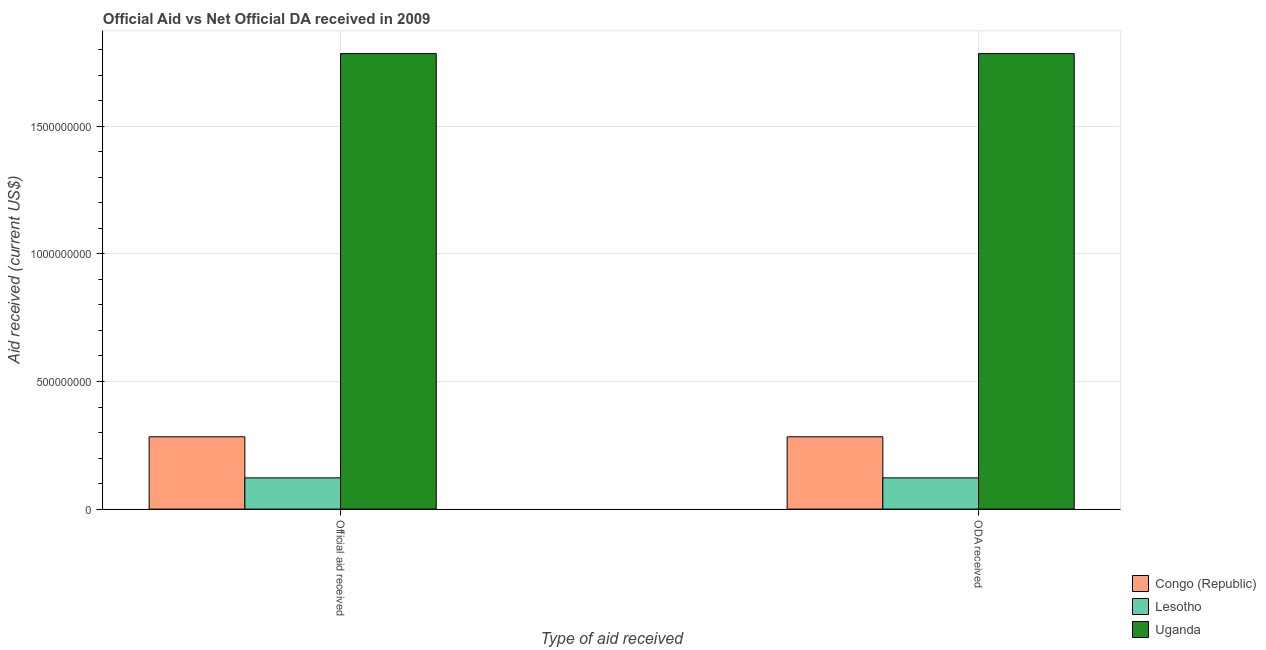How many different coloured bars are there?
Provide a succinct answer. 3. How many bars are there on the 2nd tick from the right?
Provide a short and direct response. 3. What is the label of the 2nd group of bars from the left?
Your response must be concise. ODA received. What is the oda received in Lesotho?
Ensure brevity in your answer.  1.22e+08. Across all countries, what is the maximum official aid received?
Provide a short and direct response. 1.78e+09. Across all countries, what is the minimum official aid received?
Your answer should be compact. 1.22e+08. In which country was the oda received maximum?
Offer a terse response. Uganda. In which country was the oda received minimum?
Offer a very short reply. Lesotho. What is the total oda received in the graph?
Provide a succinct answer. 2.19e+09. What is the difference between the oda received in Uganda and that in Lesotho?
Give a very brief answer. 1.66e+09. What is the difference between the oda received in Uganda and the official aid received in Congo (Republic)?
Provide a short and direct response. 1.50e+09. What is the average official aid received per country?
Give a very brief answer. 7.30e+08. What is the difference between the official aid received and oda received in Uganda?
Offer a very short reply. 0. What is the ratio of the official aid received in Uganda to that in Congo (Republic)?
Ensure brevity in your answer.  6.3. Is the official aid received in Congo (Republic) less than that in Uganda?
Provide a short and direct response. Yes. What does the 3rd bar from the left in ODA received represents?
Give a very brief answer. Uganda. What does the 1st bar from the right in ODA received represents?
Ensure brevity in your answer.  Uganda. What is the difference between two consecutive major ticks on the Y-axis?
Provide a short and direct response. 5.00e+08. Does the graph contain any zero values?
Your answer should be very brief. No. Where does the legend appear in the graph?
Keep it short and to the point. Bottom right. What is the title of the graph?
Keep it short and to the point. Official Aid vs Net Official DA received in 2009 . Does "Greece" appear as one of the legend labels in the graph?
Give a very brief answer. No. What is the label or title of the X-axis?
Give a very brief answer. Type of aid received. What is the label or title of the Y-axis?
Offer a very short reply. Aid received (current US$). What is the Aid received (current US$) of Congo (Republic) in Official aid received?
Provide a short and direct response. 2.83e+08. What is the Aid received (current US$) in Lesotho in Official aid received?
Make the answer very short. 1.22e+08. What is the Aid received (current US$) in Uganda in Official aid received?
Your answer should be very brief. 1.78e+09. What is the Aid received (current US$) in Congo (Republic) in ODA received?
Offer a terse response. 2.83e+08. What is the Aid received (current US$) of Lesotho in ODA received?
Provide a succinct answer. 1.22e+08. What is the Aid received (current US$) of Uganda in ODA received?
Offer a very short reply. 1.78e+09. Across all Type of aid received, what is the maximum Aid received (current US$) in Congo (Republic)?
Give a very brief answer. 2.83e+08. Across all Type of aid received, what is the maximum Aid received (current US$) in Lesotho?
Offer a very short reply. 1.22e+08. Across all Type of aid received, what is the maximum Aid received (current US$) of Uganda?
Offer a terse response. 1.78e+09. Across all Type of aid received, what is the minimum Aid received (current US$) of Congo (Republic)?
Your answer should be very brief. 2.83e+08. Across all Type of aid received, what is the minimum Aid received (current US$) of Lesotho?
Offer a terse response. 1.22e+08. Across all Type of aid received, what is the minimum Aid received (current US$) of Uganda?
Your response must be concise. 1.78e+09. What is the total Aid received (current US$) in Congo (Republic) in the graph?
Keep it short and to the point. 5.67e+08. What is the total Aid received (current US$) of Lesotho in the graph?
Make the answer very short. 2.45e+08. What is the total Aid received (current US$) of Uganda in the graph?
Offer a very short reply. 3.57e+09. What is the difference between the Aid received (current US$) in Lesotho in Official aid received and that in ODA received?
Ensure brevity in your answer.  0. What is the difference between the Aid received (current US$) of Uganda in Official aid received and that in ODA received?
Your answer should be very brief. 0. What is the difference between the Aid received (current US$) of Congo (Republic) in Official aid received and the Aid received (current US$) of Lesotho in ODA received?
Your answer should be very brief. 1.61e+08. What is the difference between the Aid received (current US$) in Congo (Republic) in Official aid received and the Aid received (current US$) in Uganda in ODA received?
Make the answer very short. -1.50e+09. What is the difference between the Aid received (current US$) in Lesotho in Official aid received and the Aid received (current US$) in Uganda in ODA received?
Ensure brevity in your answer.  -1.66e+09. What is the average Aid received (current US$) of Congo (Republic) per Type of aid received?
Your answer should be very brief. 2.83e+08. What is the average Aid received (current US$) in Lesotho per Type of aid received?
Your answer should be very brief. 1.22e+08. What is the average Aid received (current US$) in Uganda per Type of aid received?
Your response must be concise. 1.78e+09. What is the difference between the Aid received (current US$) of Congo (Republic) and Aid received (current US$) of Lesotho in Official aid received?
Provide a succinct answer. 1.61e+08. What is the difference between the Aid received (current US$) in Congo (Republic) and Aid received (current US$) in Uganda in Official aid received?
Your answer should be very brief. -1.50e+09. What is the difference between the Aid received (current US$) in Lesotho and Aid received (current US$) in Uganda in Official aid received?
Your answer should be compact. -1.66e+09. What is the difference between the Aid received (current US$) of Congo (Republic) and Aid received (current US$) of Lesotho in ODA received?
Offer a very short reply. 1.61e+08. What is the difference between the Aid received (current US$) in Congo (Republic) and Aid received (current US$) in Uganda in ODA received?
Your response must be concise. -1.50e+09. What is the difference between the Aid received (current US$) of Lesotho and Aid received (current US$) of Uganda in ODA received?
Your answer should be very brief. -1.66e+09. What is the ratio of the Aid received (current US$) in Congo (Republic) in Official aid received to that in ODA received?
Offer a very short reply. 1. What is the ratio of the Aid received (current US$) in Lesotho in Official aid received to that in ODA received?
Give a very brief answer. 1. What is the difference between the highest and the second highest Aid received (current US$) in Congo (Republic)?
Keep it short and to the point. 0. What is the difference between the highest and the second highest Aid received (current US$) in Lesotho?
Offer a terse response. 0. What is the difference between the highest and the second highest Aid received (current US$) in Uganda?
Make the answer very short. 0. What is the difference between the highest and the lowest Aid received (current US$) of Congo (Republic)?
Provide a short and direct response. 0. What is the difference between the highest and the lowest Aid received (current US$) in Lesotho?
Give a very brief answer. 0. What is the difference between the highest and the lowest Aid received (current US$) of Uganda?
Your response must be concise. 0. 